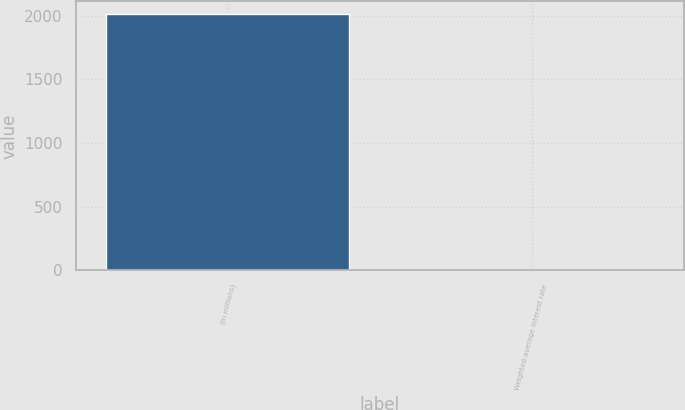Convert chart to OTSL. <chart><loc_0><loc_0><loc_500><loc_500><bar_chart><fcel>(in millions)<fcel>Weighted-average interest rate<nl><fcel>2013<fcel>0.34<nl></chart> 